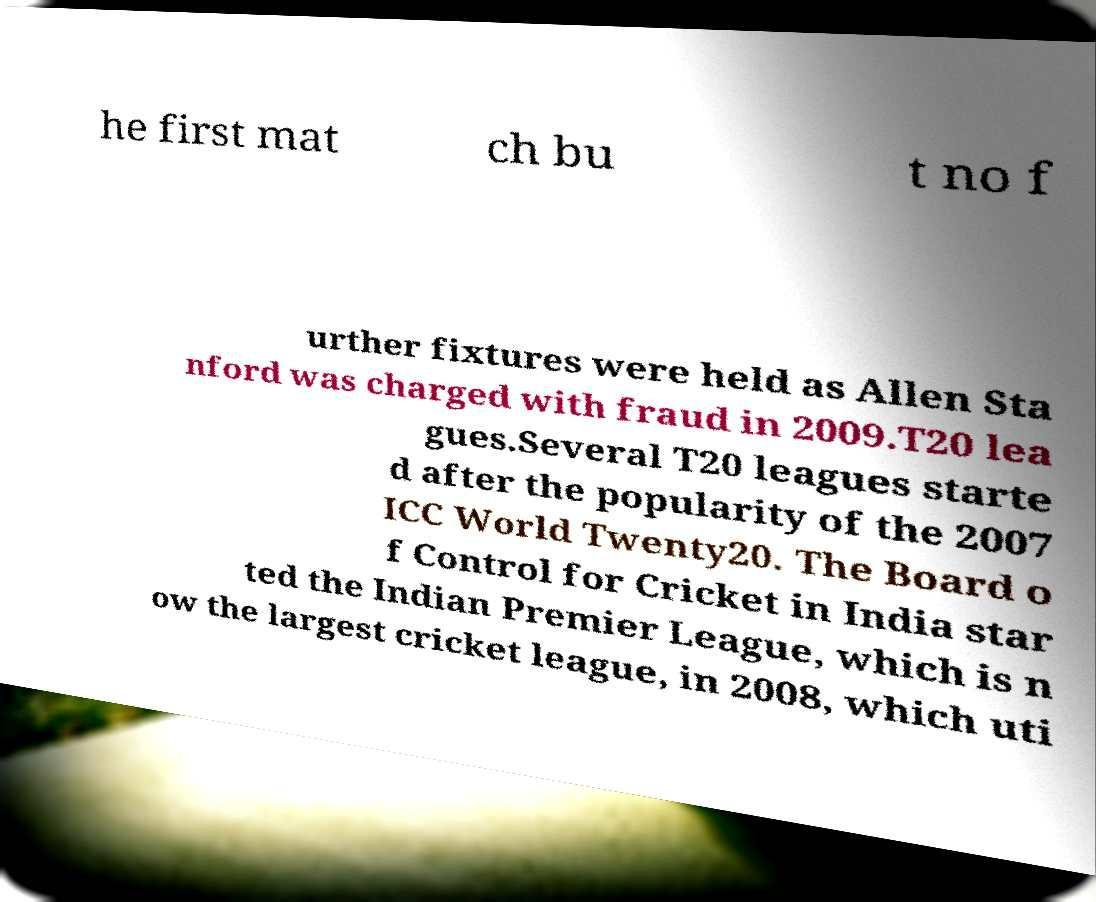What messages or text are displayed in this image? I need them in a readable, typed format. he first mat ch bu t no f urther fixtures were held as Allen Sta nford was charged with fraud in 2009.T20 lea gues.Several T20 leagues starte d after the popularity of the 2007 ICC World Twenty20. The Board o f Control for Cricket in India star ted the Indian Premier League, which is n ow the largest cricket league, in 2008, which uti 